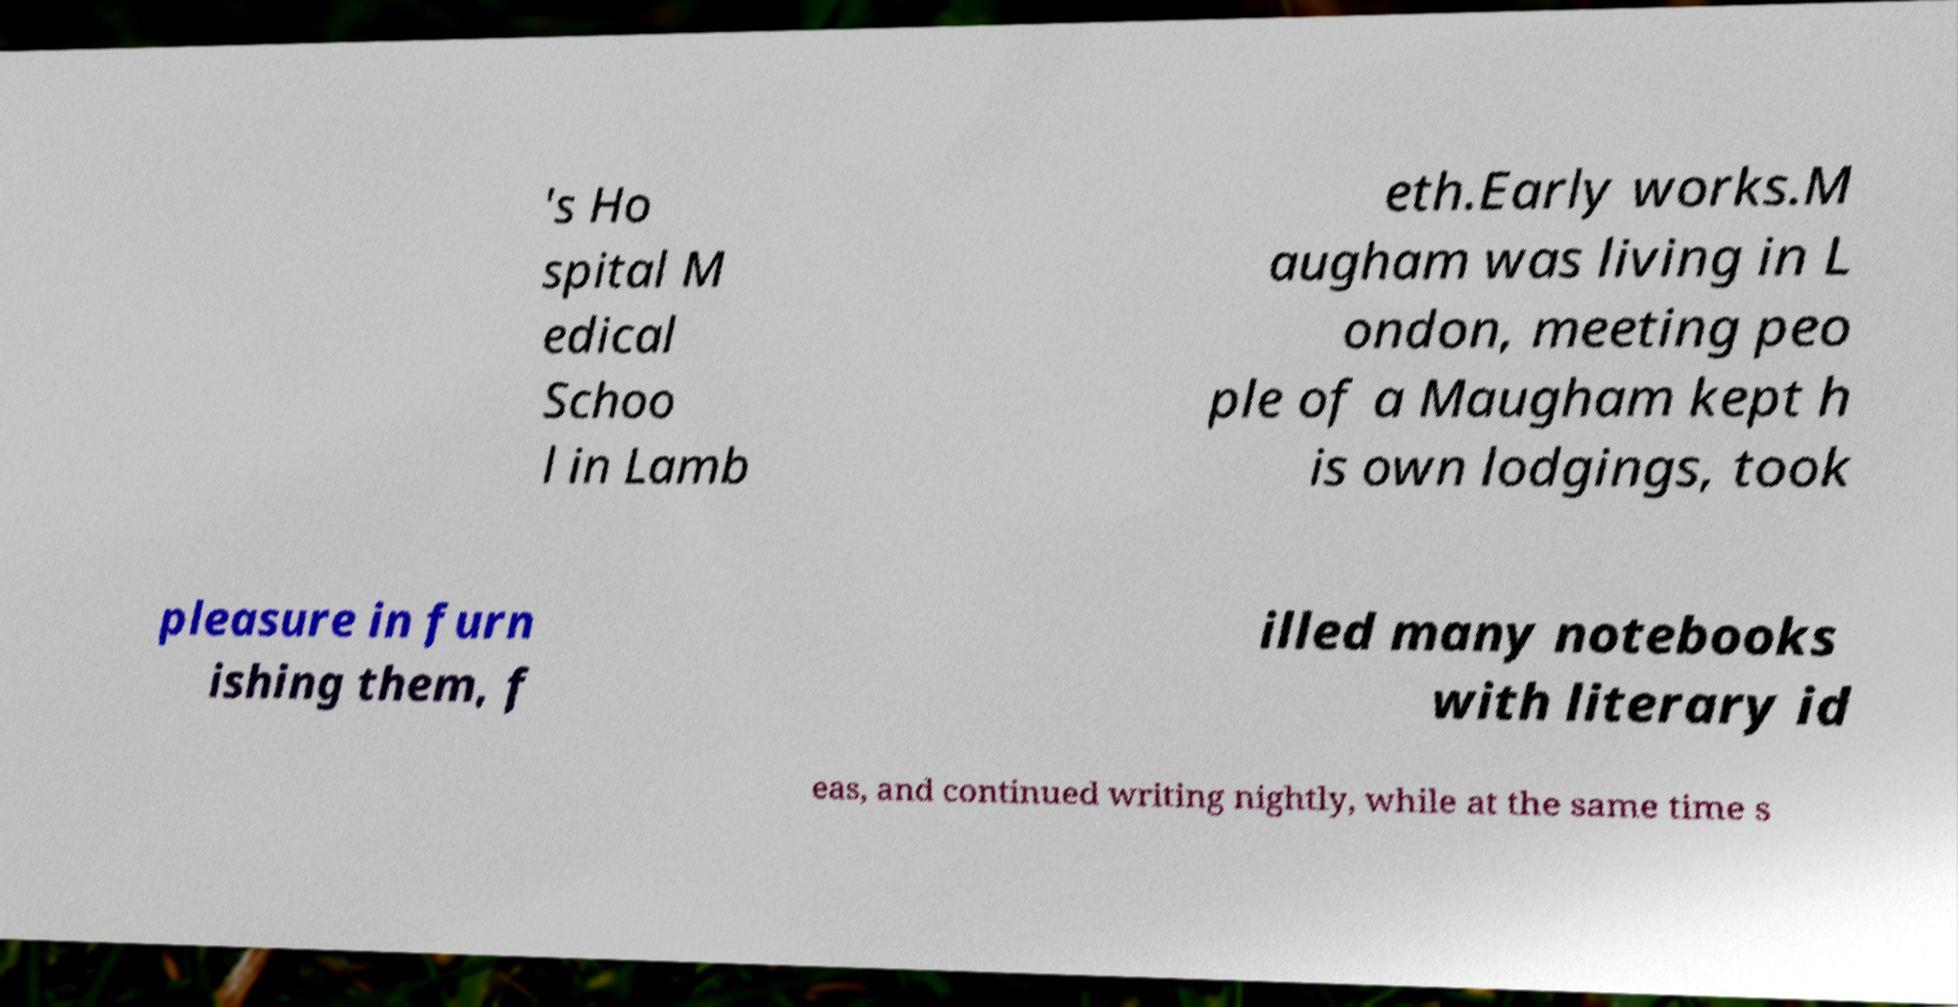Please read and relay the text visible in this image. What does it say? 's Ho spital M edical Schoo l in Lamb eth.Early works.M augham was living in L ondon, meeting peo ple of a Maugham kept h is own lodgings, took pleasure in furn ishing them, f illed many notebooks with literary id eas, and continued writing nightly, while at the same time s 